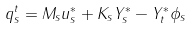Convert formula to latex. <formula><loc_0><loc_0><loc_500><loc_500>q _ { s } ^ { t } = M _ { s } u _ { s } ^ { * } + K _ { s } Y _ { s } ^ { * } - Y _ { t } ^ { * } \phi _ { s }</formula> 